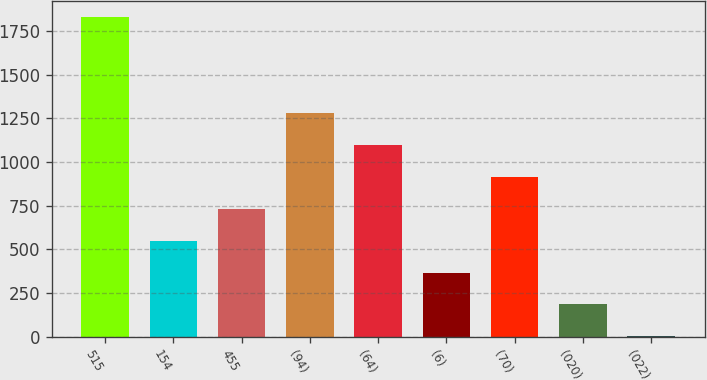<chart> <loc_0><loc_0><loc_500><loc_500><bar_chart><fcel>515<fcel>154<fcel>455<fcel>(94)<fcel>(64)<fcel>(6)<fcel>(70)<fcel>(020)<fcel>(022)<nl><fcel>1827<fcel>549.68<fcel>732.15<fcel>1279.56<fcel>1097.09<fcel>367.21<fcel>914.62<fcel>184.74<fcel>2.27<nl></chart> 